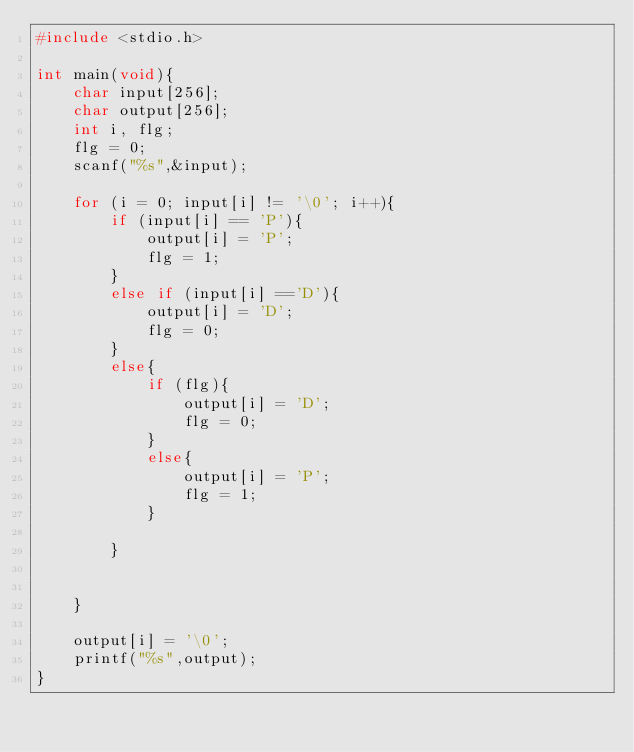<code> <loc_0><loc_0><loc_500><loc_500><_C_>#include <stdio.h>

int main(void){
    char input[256];
    char output[256];
    int i, flg;
    flg = 0;
    scanf("%s",&input);

    for (i = 0; input[i] != '\0'; i++){
        if (input[i] == 'P'){
            output[i] = 'P';
            flg = 1;
        }
        else if (input[i] =='D'){
            output[i] = 'D';
            flg = 0;
        }
        else{
            if (flg){
                output[i] = 'D';
                flg = 0;
            }
            else{
                output[i] = 'P';
                flg = 1;
            }

        }


    }

    output[i] = '\0';
    printf("%s",output);
}</code> 